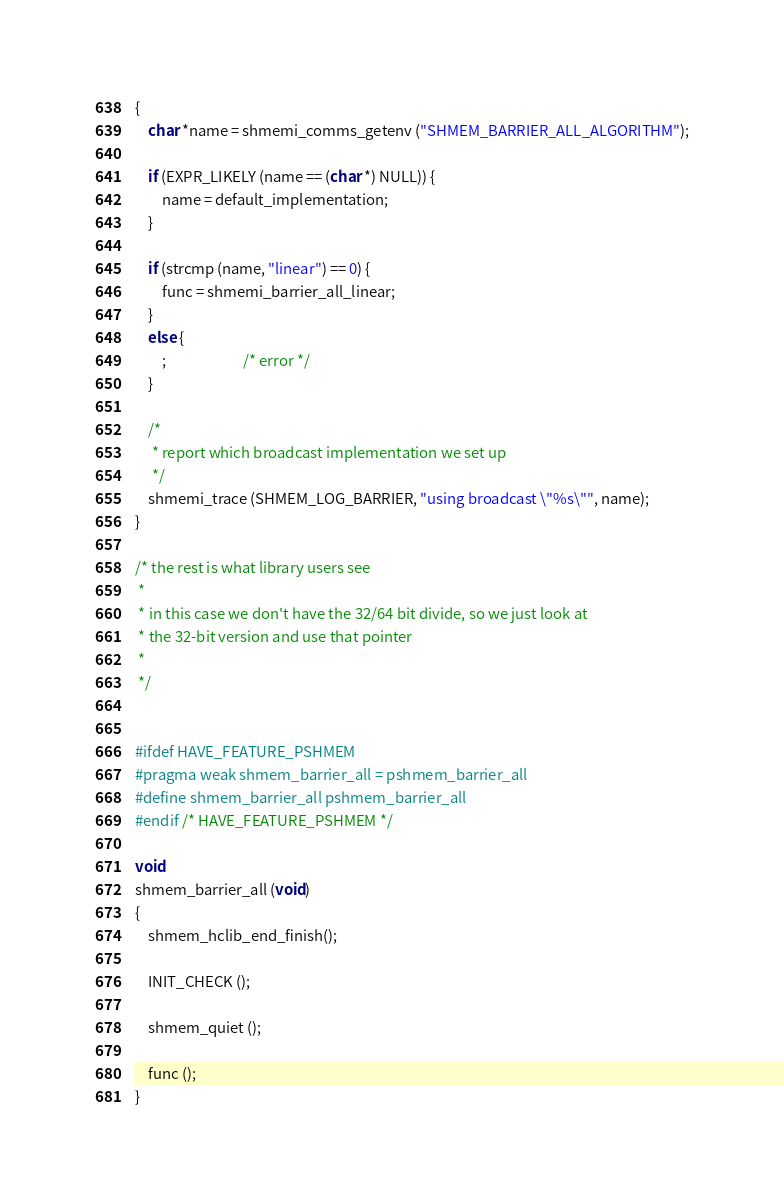<code> <loc_0><loc_0><loc_500><loc_500><_C_>{
    char *name = shmemi_comms_getenv ("SHMEM_BARRIER_ALL_ALGORITHM");

    if (EXPR_LIKELY (name == (char *) NULL)) {
        name = default_implementation;
    }

    if (strcmp (name, "linear") == 0) {
        func = shmemi_barrier_all_linear;
    }
    else {
        ;                       /* error */
    }

    /*
     * report which broadcast implementation we set up
     */
    shmemi_trace (SHMEM_LOG_BARRIER, "using broadcast \"%s\"", name);
}

/* the rest is what library users see
 *
 * in this case we don't have the 32/64 bit divide, so we just look at
 * the 32-bit version and use that pointer
 *
 */


#ifdef HAVE_FEATURE_PSHMEM
#pragma weak shmem_barrier_all = pshmem_barrier_all
#define shmem_barrier_all pshmem_barrier_all
#endif /* HAVE_FEATURE_PSHMEM */

void
shmem_barrier_all (void)
{
    shmem_hclib_end_finish();

    INIT_CHECK ();

    shmem_quiet ();

    func ();
}
</code> 